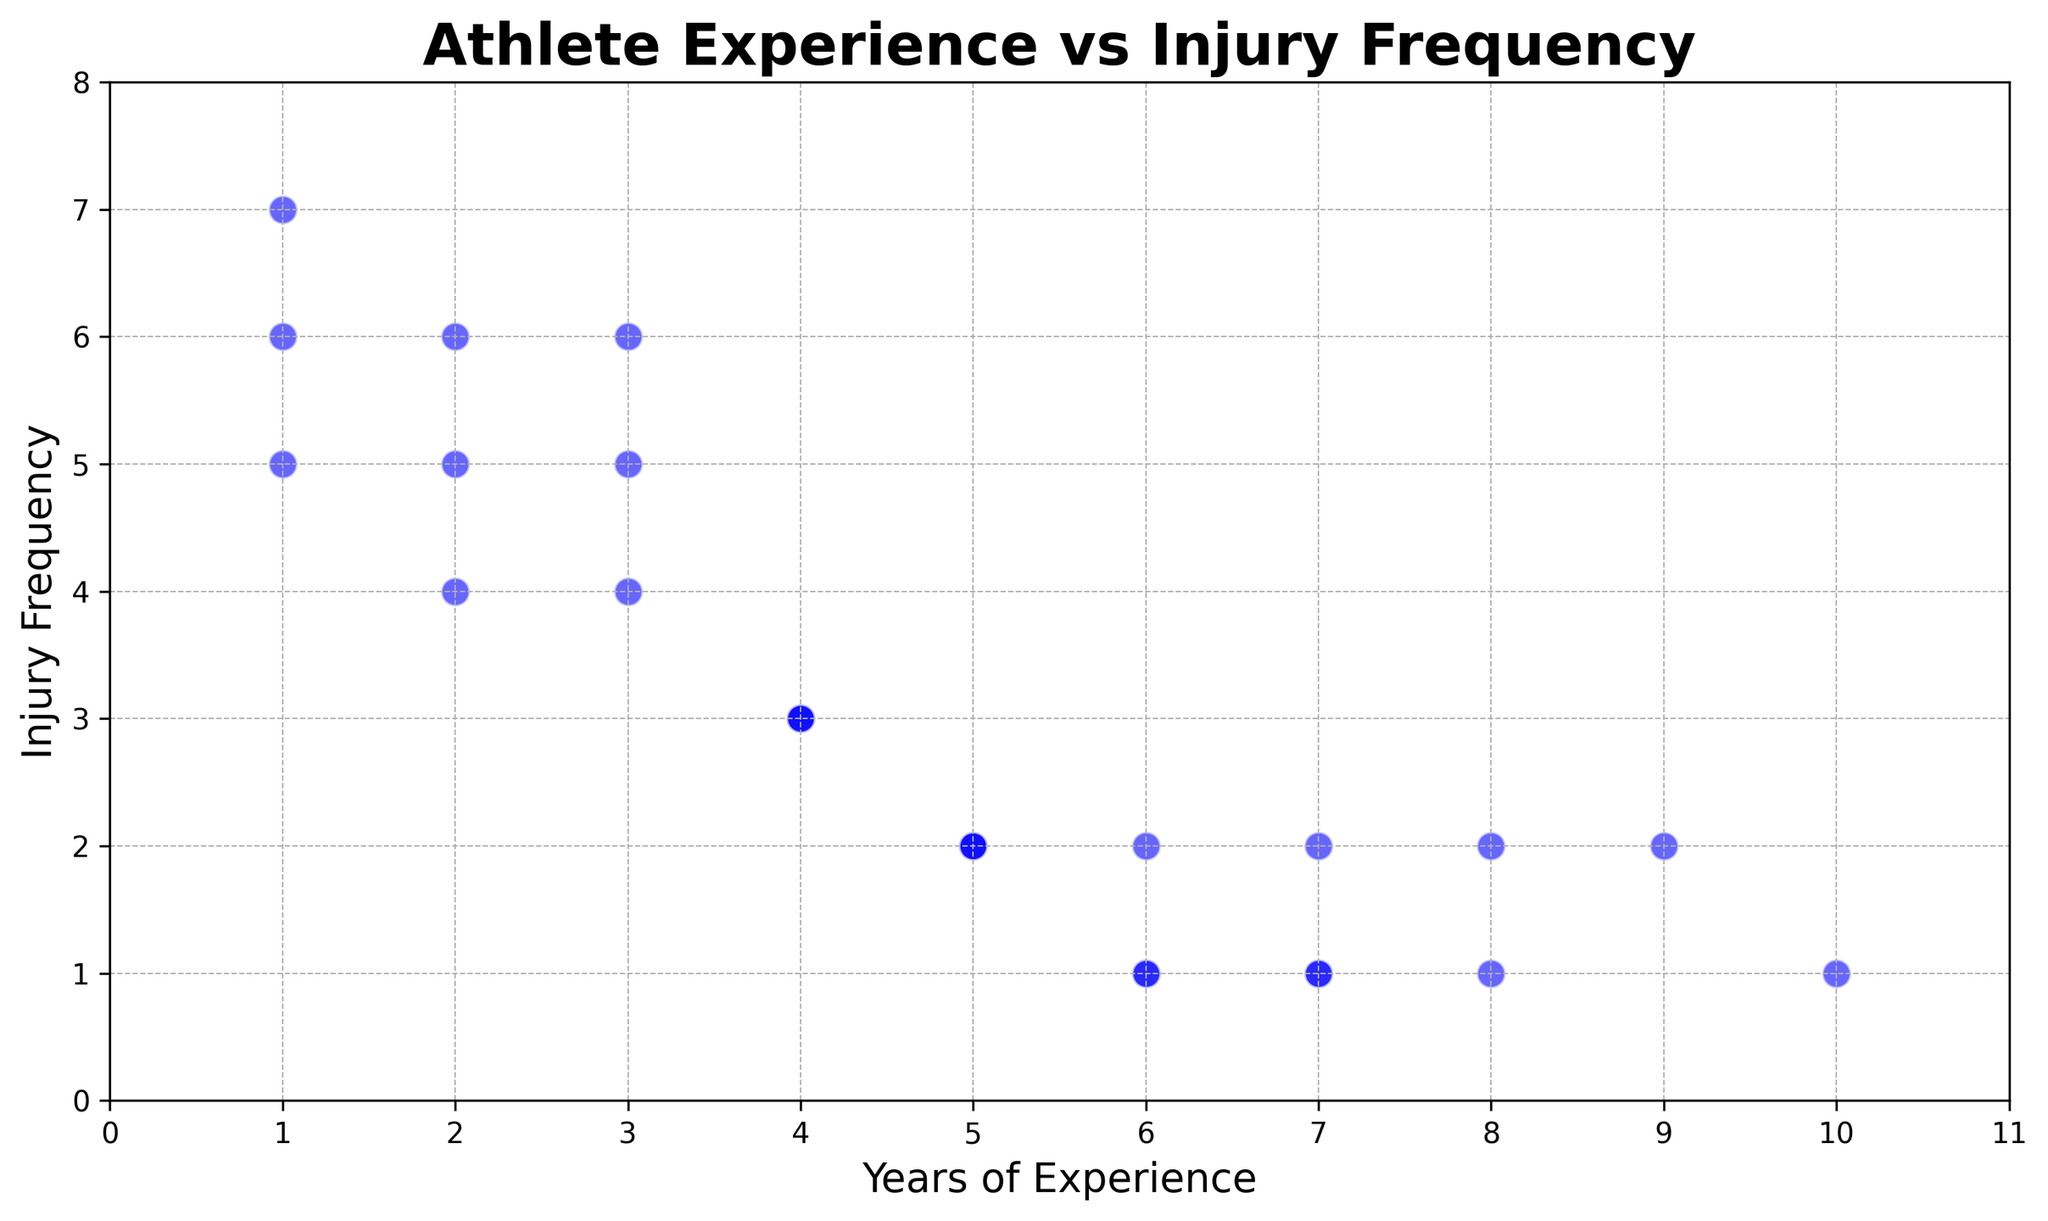How many data points show an injury frequency of 1? Count the number of points at y=1 on the vertical axis. There are four points with injury frequency of 1.
Answer: 4 Does injury frequency decrease as experience increases? Observe the trend of points as experience (x-axis) increases. Injury frequency generally tends to decrease as years of experience increase.
Answer: Yes What is the maximum injury frequency in the dataset? Identify the highest value on the vertical axis (Injury Frequency). The maximum injury frequency is 7.
Answer: 7 Which experience level is associated with the lowest average injury frequency? Compute the average injury frequency for each experience level and compare them. Experience levels 6 and 7 have the lowest injury frequency (average is 1 and 1.17, respectively).
Answer: 6 and 7 How many athletes with 2 years of experience have an injury frequency greater than 5? Count the data points with experience = 2 and injury frequency > 5. There are 2 such points.
Answer: 2 Compare the number of athletes with 3 years of experience to those with 5 years of experience. Count the data points at x=3 (5 points) and x=5 (4 points). There are 5 athletes with 3 years of experience and 4 athletes with 5 years of experience.
Answer: 3 years: 5, 5 years: 4 What is the average injury frequency for athletes with more than 5 years of experience? Calculate the average injury frequency for points where experience > 5. The respective injury frequencies are 1, 2, 2, 1, 2, 1. Average = (1+2+2+1+2+1)/6 = 1.5.
Answer: 1.5 Are there any outliers in the scatter plot? Observe any points that are significantly distant from others. The point (1, 7) could be considered an outlier.
Answer: Yes Which experience level has the most consistent injury frequency? Identify the experience level with the least variation in injury frequency. Levels 6, 7, and 10 have very consistent injury frequencies (all are 1 or 2).
Answer: 6, 7, 10 What is the range of injury frequencies for athletes with 4 years of experience? Identify the minimum and maximum injury frequencies for 4 years of experience. The injury frequencies are 3. So the range is 3-3 = 0.
Answer: 0 